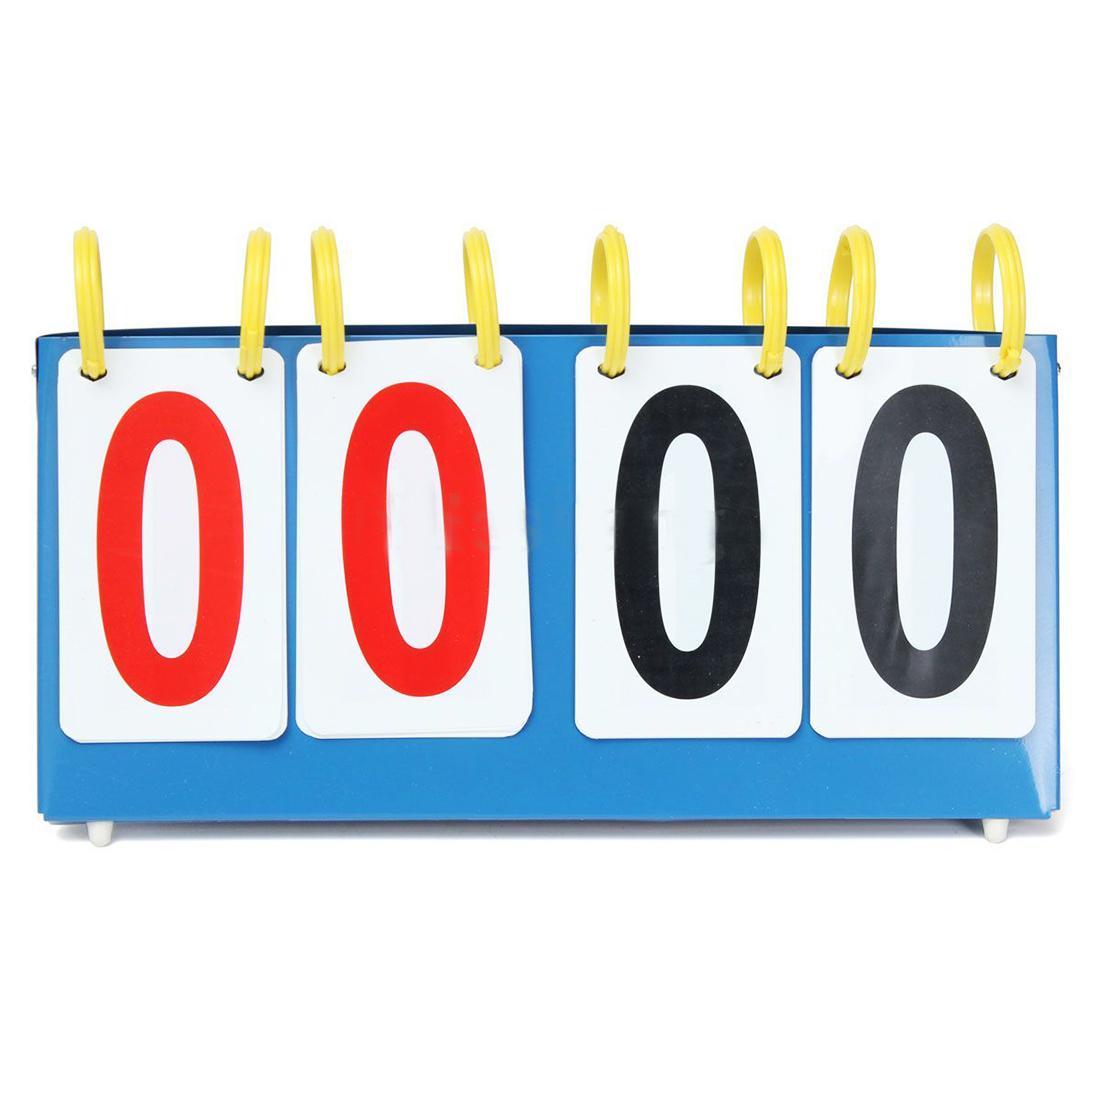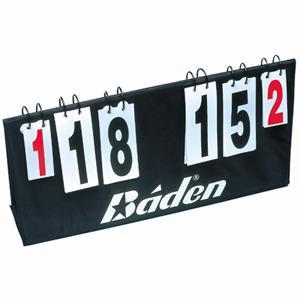The first image is the image on the left, the second image is the image on the right. Examine the images to the left and right. Is the description "In at least one image there is a total of four zeros." accurate? Answer yes or no. Yes. The first image is the image on the left, the second image is the image on the right. Given the left and right images, does the statement "There are eight rings in the left image." hold true? Answer yes or no. Yes. 